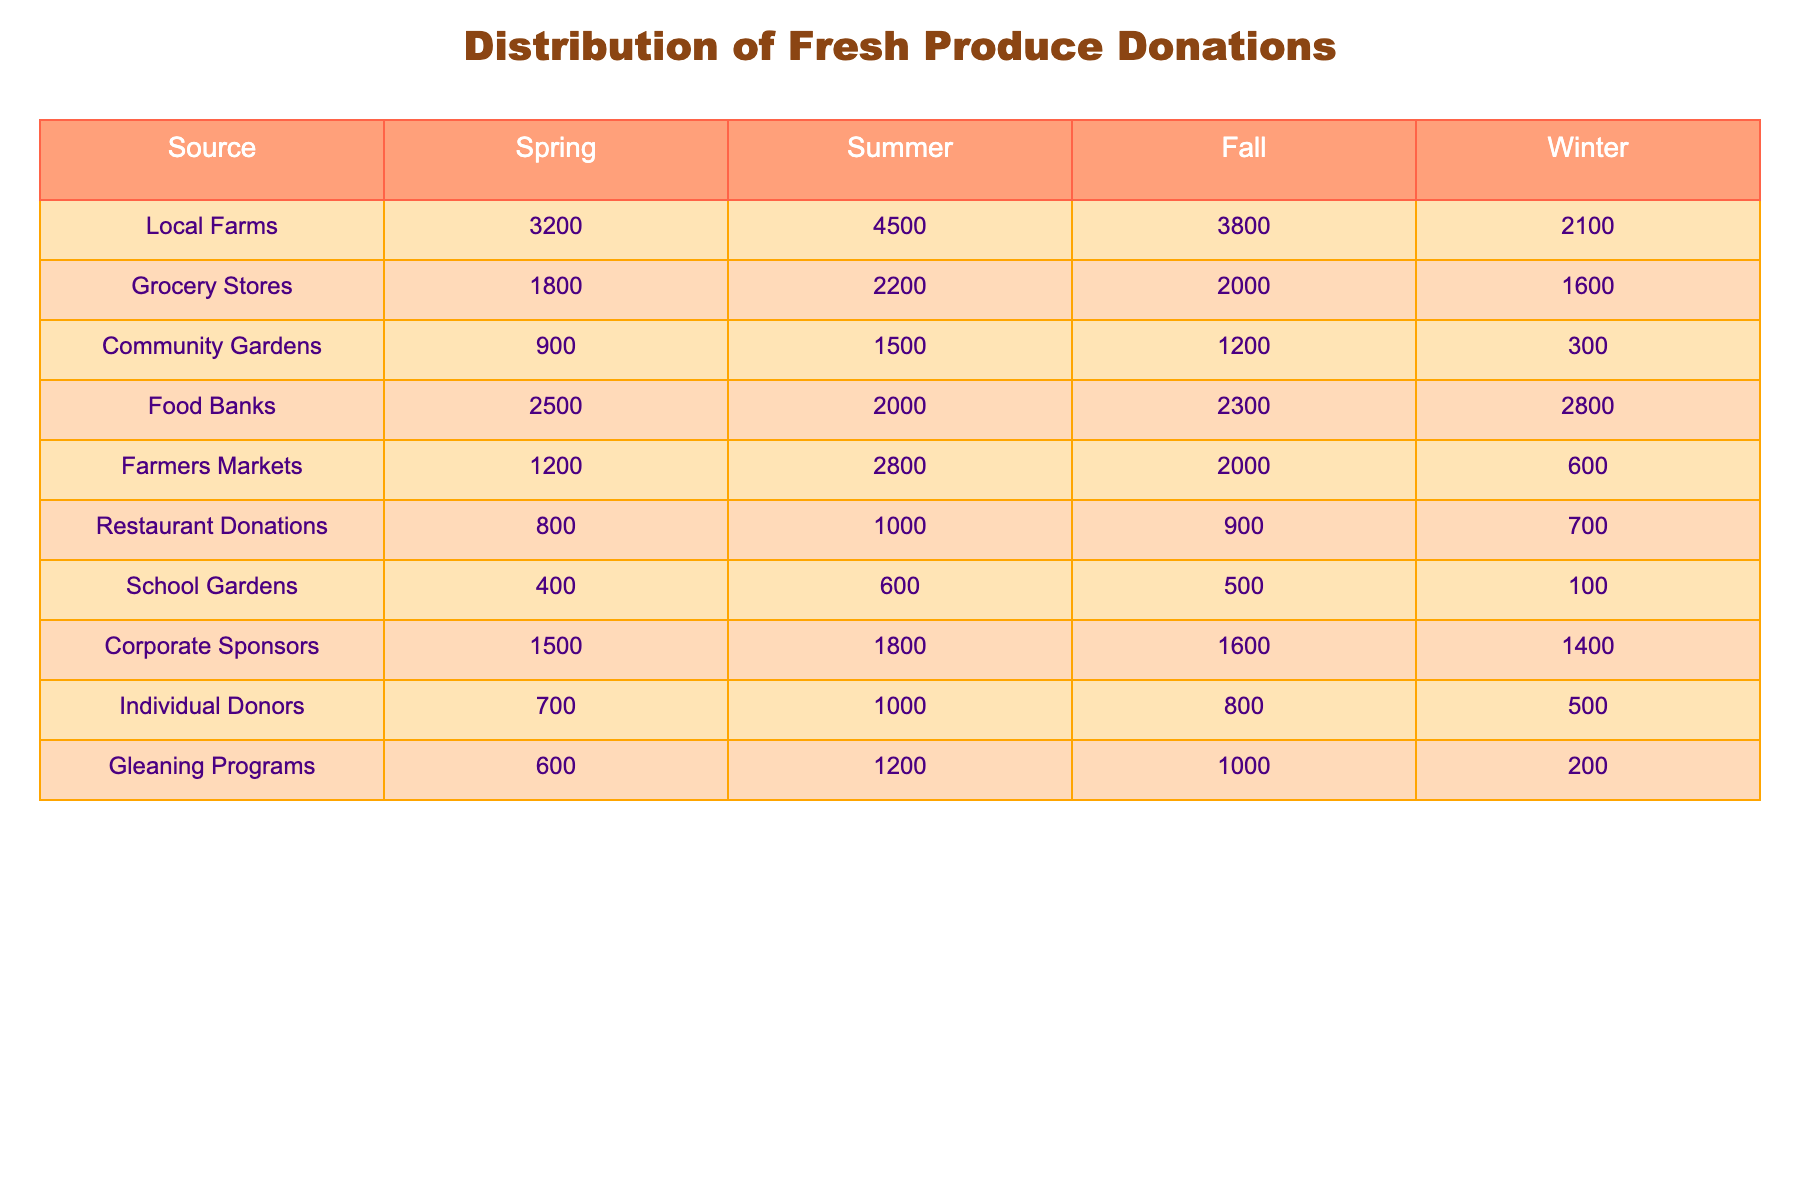What is the total amount of fresh produce donations from Local Farms? The total donations from Local Farms can be found by looking at the values in the Spring, Summer, Fall, and Winter columns for Local Farms. The values are 3200 (Spring) + 4500 (Summer) + 3800 (Fall) + 2100 (Winter). Adding these gives 3200 + 4500 + 3800 + 2100 = 13600.
Answer: 13600 Which source provided the least amount of fresh produce donations in Winter? To find the source with the least donations in Winter, we look at the Winter column. The values for Winter are: Local Farms (2100), Grocery Stores (1600), Community Gardens (300), Food Banks (2800), Farmers Markets (600), Restaurant Donations (700), School Gardens (100), Corporate Sponsors (1400), Individual Donors (500), Gleaning Programs (200). The smallest value is 200, from Gleaning Programs.
Answer: Gleaning Programs What source contributed the most donations in Fall? The Fall donations are as follows: Local Farms (3800), Grocery Stores (2000), Community Gardens (1200), Food Banks (2300), Farmers Markets (2000), Restaurant Donations (900), School Gardens (500), Corporate Sponsors (1600), Individual Donors (800), Gleaning Programs (1000). The highest value is 3800 from Local Farms.
Answer: Local Farms What is the average amount of donations from Grocery Stores across all seasons? To calculate the average, we first sum the donations from Grocery Stores which are 1800 (Spring), 2200 (Summer), 2000 (Fall), and 1600 (Winter). The total is 1800 + 2200 + 2000 + 1600 = 7600. Since there are 4 seasons, we divide by 4: 7600 / 4 = 1900.
Answer: 1900 Is the total amount of donations from Food Banks greater than that from Farmers Markets? We first find the total donations for both sources. Food Banks: 2500 + 2000 + 2300 + 2800 = 9600. Farmers Markets: 1200 + 2800 + 2000 + 600 = 6600. Since 9600 > 6600, the statement is true.
Answer: Yes What is the difference in fresh produce donations between Summer and Winter for Corporate Sponsors? For Corporate Sponsors, the values are 1800 (Summer) and 1400 (Winter). The difference is 1800 - 1400 = 400.
Answer: 400 Which source has the highest total donations and what is the value? We need to sum the donations for each source: Local Farms = 13600, Grocery Stores = 7600, Community Gardens = 3900, Food Banks = 9600, Farmers Markets = 6600, Restaurant Donations = 3400, School Gardens = 1600, Corporate Sponsors = 6400, Individual Donors = 3000, Gleaning Programs = 2100. The highest total is 13600 from Local Farms.
Answer: Local Farms, 13600 In which season did Individual Donors contribute the least amount and what is that amount? The amounts for Individual Donors are: 700 (Spring), 1000 (Summer), 800 (Fall), and 500 (Winter). The lowest value is 500 from Winter.
Answer: Winter, 500 What is the relationship between the donations from Community Gardens and Restaurant Donations in Spring? The donations are 900 from Community Gardens and 800 from Restaurant Donations in Spring. The relationship shows that Community Gardens donated more by 900 - 800 = 100.
Answer: Community Gardens donated 100 more If we combine all donations from Summer, which source contributed the most and by how much compared to the second highest source? For Summer, the donations are: Local Farms (4500), Grocery Stores (2200), Community Gardens (1500), Food Banks (2000), Farmers Markets (2800), Restaurant Donations (1000), School Gardens (600), Corporate Sponsors (1800), Individual Donors (1000), Gleaning Programs (1200). Local Farms has the highest with 4500, and the second highest source is Farmers Markets with 2800. The difference is 4500 - 2800 = 1700.
Answer: Local Farms, 1700 